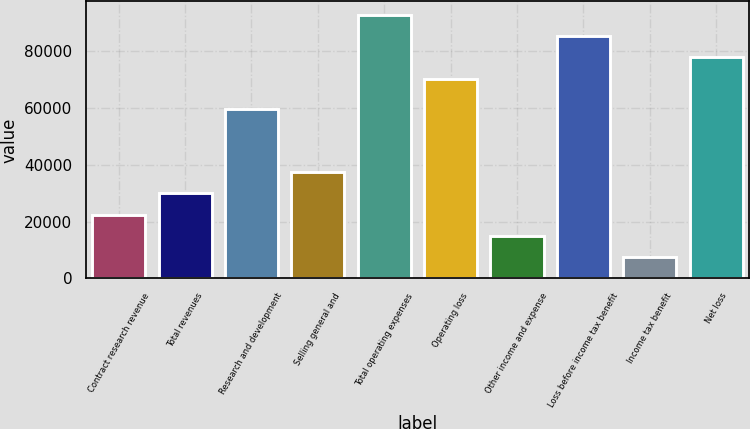Convert chart to OTSL. <chart><loc_0><loc_0><loc_500><loc_500><bar_chart><fcel>Contract research revenue<fcel>Total revenues<fcel>Research and development<fcel>Selling general and<fcel>Total operating expenses<fcel>Operating loss<fcel>Other income and expense<fcel>Loss before income tax benefit<fcel>Income tax benefit<fcel>Net loss<nl><fcel>22520.1<fcel>30025.7<fcel>59840<fcel>37531.2<fcel>92966.7<fcel>70450<fcel>15014.5<fcel>85461.1<fcel>7508.99<fcel>77955.6<nl></chart> 